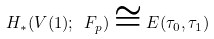Convert formula to latex. <formula><loc_0><loc_0><loc_500><loc_500>H _ { * } ( V ( 1 ) ; \ F _ { p } ) \cong E ( \tau _ { 0 } , \tau _ { 1 } )</formula> 